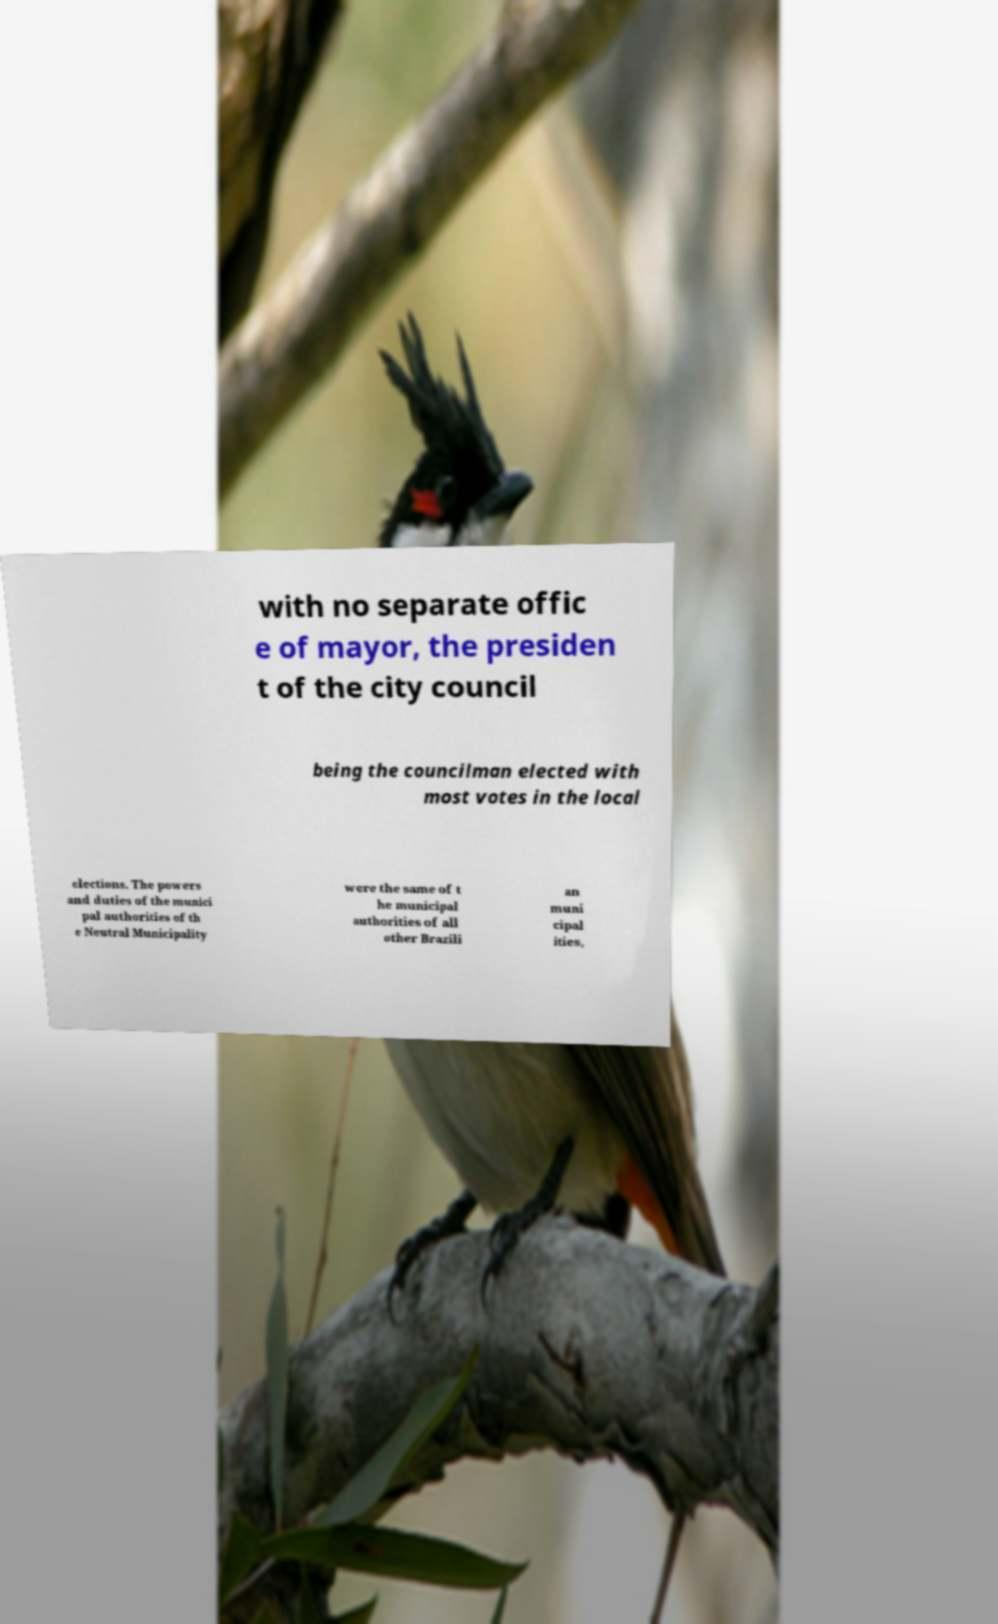Can you accurately transcribe the text from the provided image for me? with no separate offic e of mayor, the presiden t of the city council being the councilman elected with most votes in the local elections. The powers and duties of the munici pal authorities of th e Neutral Municipality were the same of t he municipal authorities of all other Brazili an muni cipal ities, 